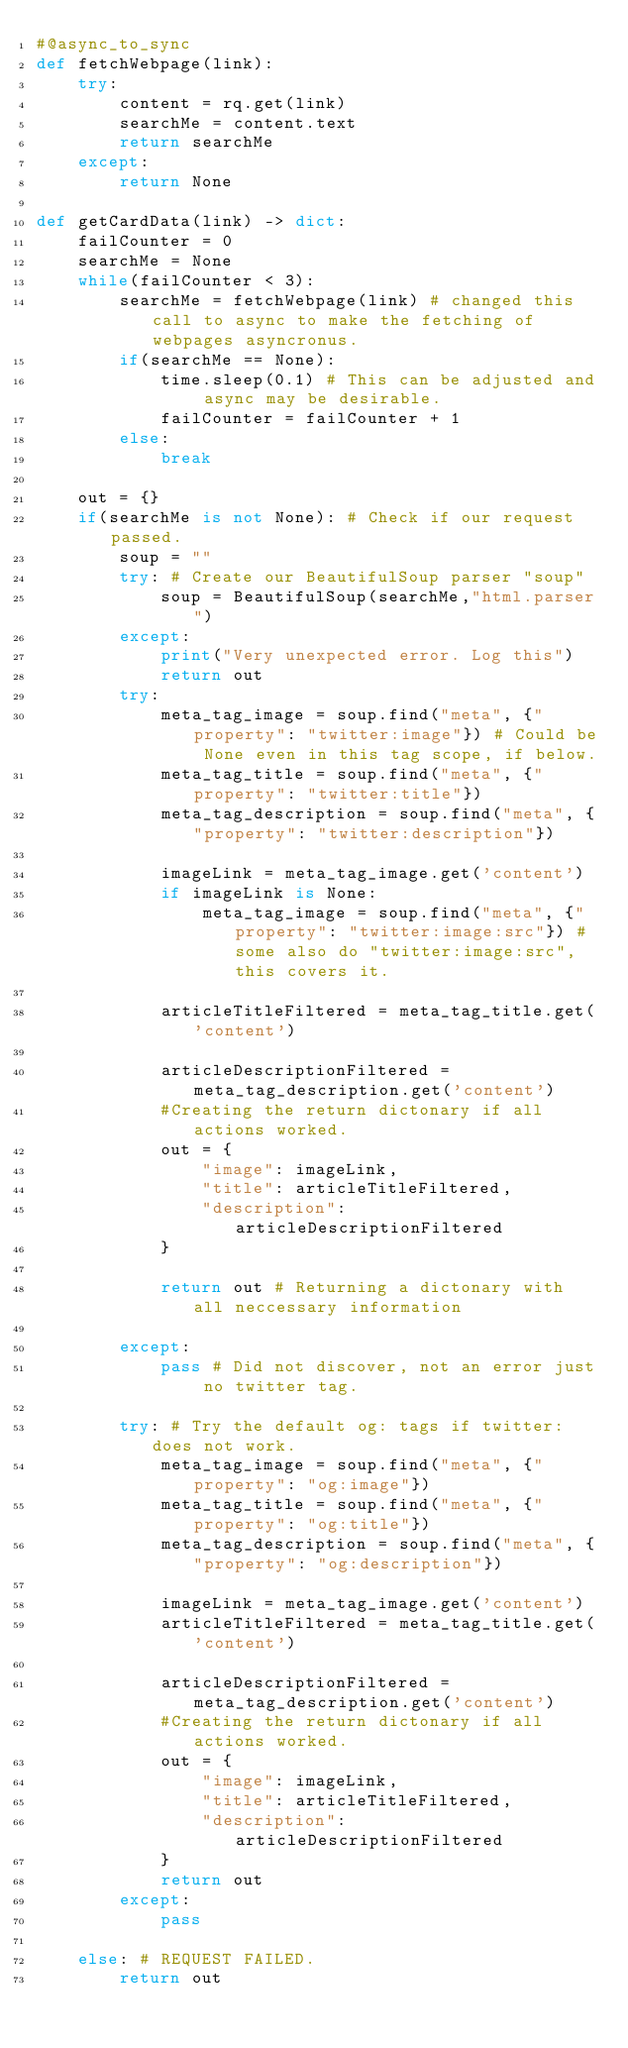Convert code to text. <code><loc_0><loc_0><loc_500><loc_500><_Python_>#@async_to_sync
def fetchWebpage(link):
    try:
        content = rq.get(link)
        searchMe = content.text
        return searchMe
    except:
        return None
    
def getCardData(link) -> dict: 
    failCounter = 0
    searchMe = None
    while(failCounter < 3):
        searchMe = fetchWebpage(link) # changed this call to async to make the fetching of webpages asyncronus.
        if(searchMe == None):
            time.sleep(0.1) # This can be adjusted and async may be desirable.
            failCounter = failCounter + 1
        else:
            break

    out = {}
    if(searchMe is not None): # Check if our request passed.
        soup = ""
        try: # Create our BeautifulSoup parser "soup"
            soup = BeautifulSoup(searchMe,"html.parser")
        except:
            print("Very unexpected error. Log this")
            return out
        try:
            meta_tag_image = soup.find("meta", {"property": "twitter:image"}) # Could be None even in this tag scope, if below.
            meta_tag_title = soup.find("meta", {"property": "twitter:title"})
            meta_tag_description = soup.find("meta", {"property": "twitter:description"})

            imageLink = meta_tag_image.get('content')
            if imageLink is None:
                meta_tag_image = soup.find("meta", {"property": "twitter:image:src"}) # some also do "twitter:image:src", this covers it.

            articleTitleFiltered = meta_tag_title.get('content')

            articleDescriptionFiltered = meta_tag_description.get('content')
            #Creating the return dictonary if all actions worked.
            out = {
                "image": imageLink,
                "title": articleTitleFiltered,
                "description": articleDescriptionFiltered
            }

            return out # Returning a dictonary with all neccessary information
            
        except:
            pass # Did not discover, not an error just no twitter tag.

        try: # Try the default og: tags if twitter: does not work.
            meta_tag_image = soup.find("meta", {"property": "og:image"})
            meta_tag_title = soup.find("meta", {"property": "og:title"})
            meta_tag_description = soup.find("meta", {"property": "og:description"})

            imageLink = meta_tag_image.get('content')
            articleTitleFiltered = meta_tag_title.get('content')

            articleDescriptionFiltered = meta_tag_description.get('content')
            #Creating the return dictonary if all actions worked.
            out = {
                "image": imageLink,
                "title": articleTitleFiltered,
                "description": articleDescriptionFiltered
            }
            return out
        except:
            pass

    else: # REQUEST FAILED.
        return out
</code> 